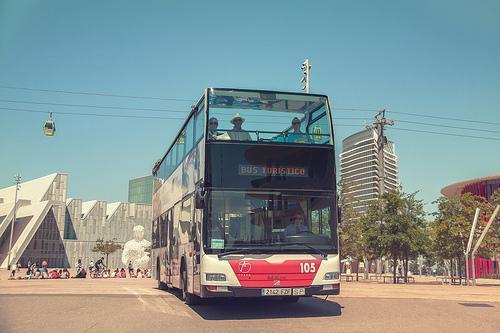How many levels on the bus?
Give a very brief answer. 2. 